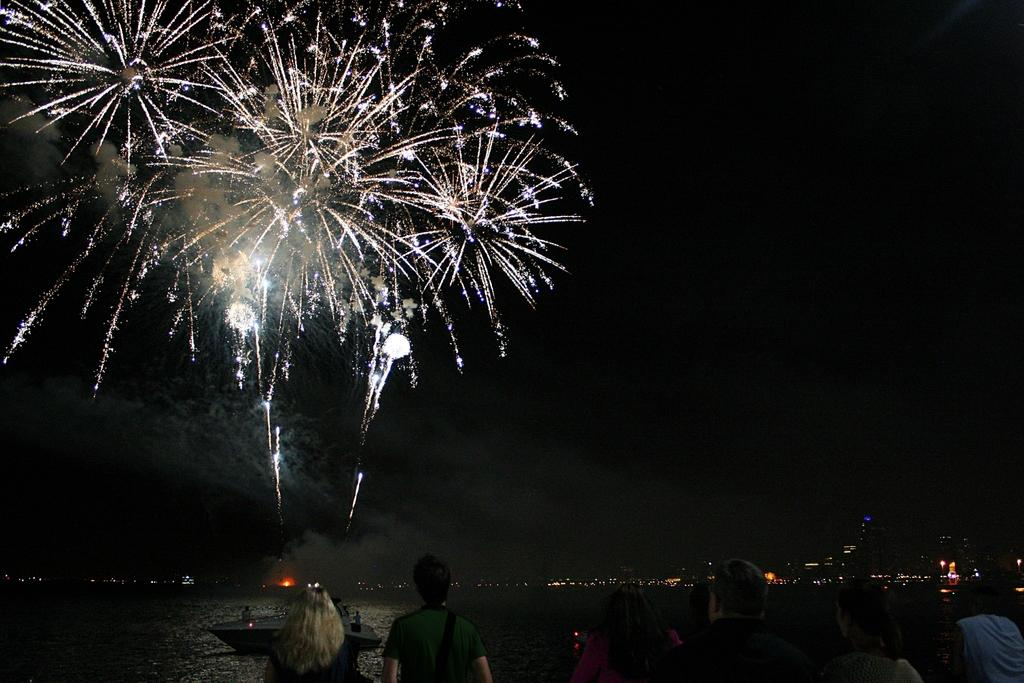What is in the water in the image? There is a boat in the water in the image. What are the people in the image doing? There is a group of people standing in the image. What can be seen in the background of the image? There are buildings with lights visible in the image. What is happening in the sky in the image? There are fireworks in the sky in the image. What type of nerve can be seen in the image? There is no nerve present in the image. Is there an alley visible in the image? There is no alley visible in the image; the image features a boat in the water, a group of people standing, buildings with lights, and fireworks in the sky. 